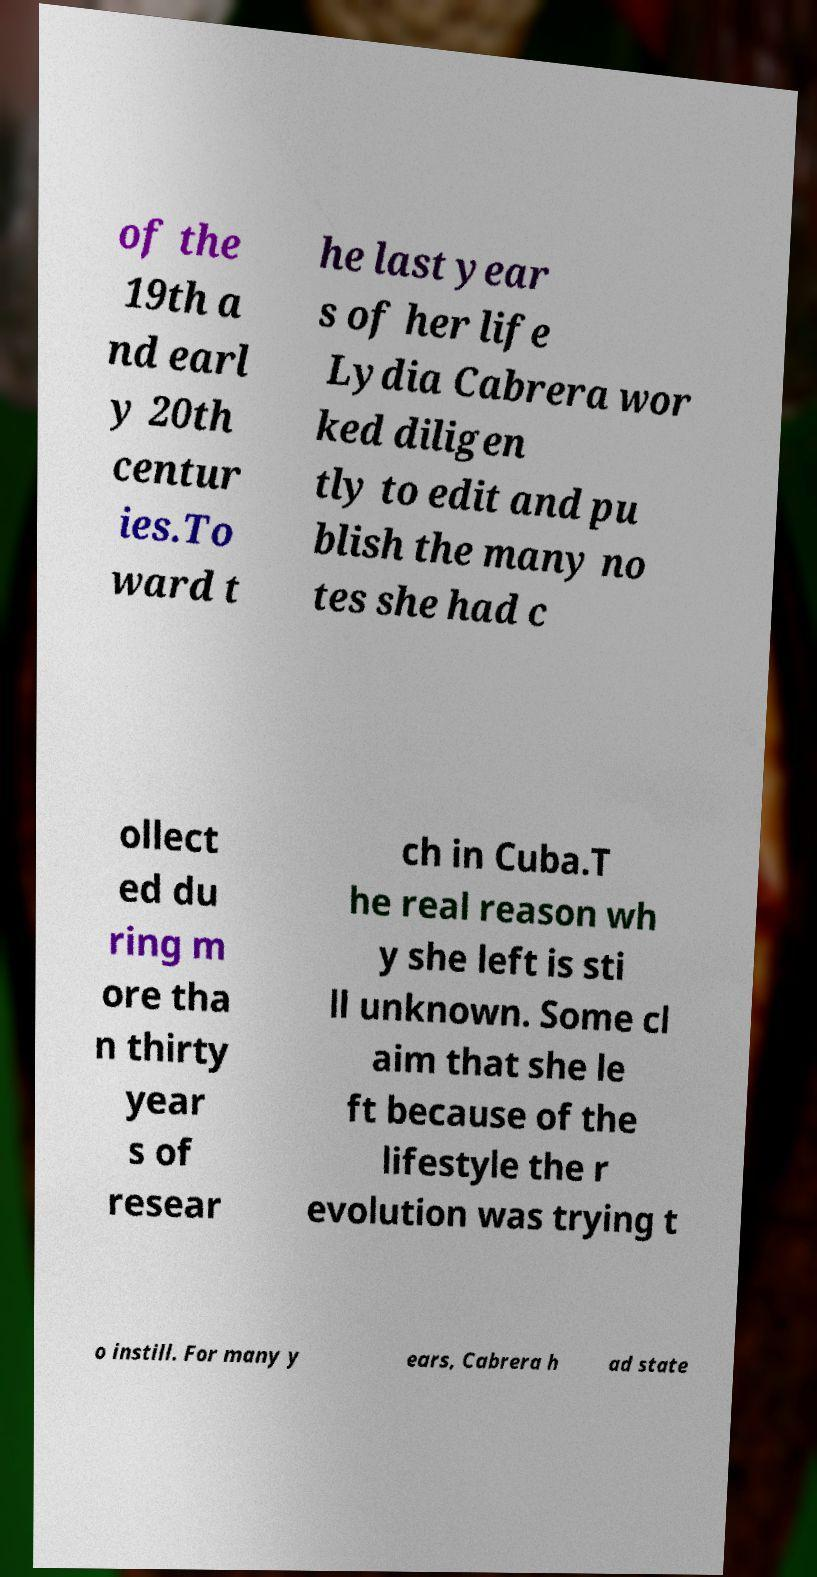Please identify and transcribe the text found in this image. of the 19th a nd earl y 20th centur ies.To ward t he last year s of her life Lydia Cabrera wor ked diligen tly to edit and pu blish the many no tes she had c ollect ed du ring m ore tha n thirty year s of resear ch in Cuba.T he real reason wh y she left is sti ll unknown. Some cl aim that she le ft because of the lifestyle the r evolution was trying t o instill. For many y ears, Cabrera h ad state 